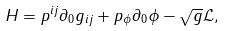<formula> <loc_0><loc_0><loc_500><loc_500>H = p ^ { i j } \partial _ { 0 } g _ { i j } + p _ { \phi } \partial _ { 0 } { \phi } - \sqrt { g } \mathcal { L } ,</formula> 